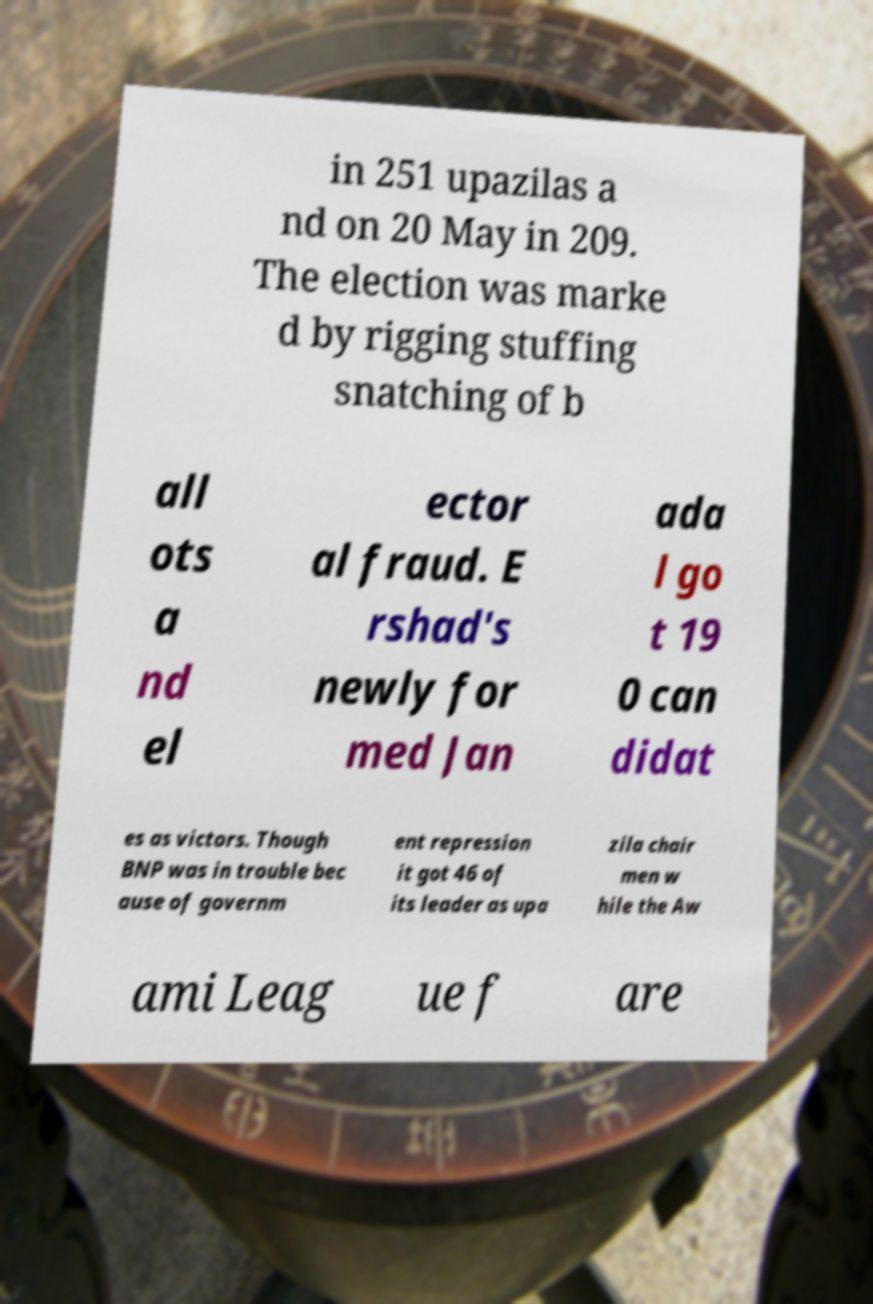There's text embedded in this image that I need extracted. Can you transcribe it verbatim? in 251 upazilas a nd on 20 May in 209. The election was marke d by rigging stuffing snatching of b all ots a nd el ector al fraud. E rshad's newly for med Jan ada l go t 19 0 can didat es as victors. Though BNP was in trouble bec ause of governm ent repression it got 46 of its leader as upa zila chair men w hile the Aw ami Leag ue f are 